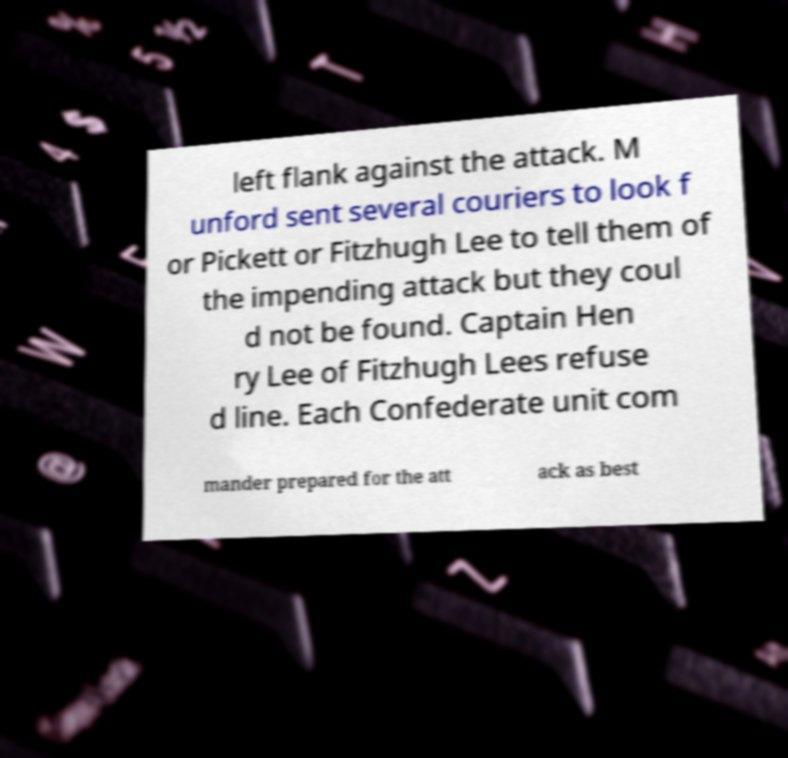Can you read and provide the text displayed in the image?This photo seems to have some interesting text. Can you extract and type it out for me? left flank against the attack. M unford sent several couriers to look f or Pickett or Fitzhugh Lee to tell them of the impending attack but they coul d not be found. Captain Hen ry Lee of Fitzhugh Lees refuse d line. Each Confederate unit com mander prepared for the att ack as best 